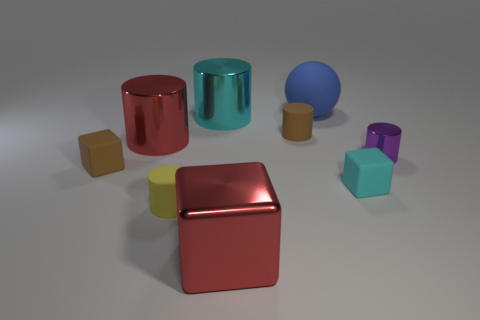Subtract all rubber cylinders. How many cylinders are left? 3 Subtract all yellow cylinders. How many cylinders are left? 4 Subtract 2 cylinders. How many cylinders are left? 3 Subtract all yellow cylinders. Subtract all gray cubes. How many cylinders are left? 4 Add 1 tiny cyan things. How many objects exist? 10 Subtract all cylinders. How many objects are left? 4 Add 1 big red rubber balls. How many big red rubber balls exist? 1 Subtract 1 cyan cylinders. How many objects are left? 8 Subtract all large matte balls. Subtract all small things. How many objects are left? 3 Add 9 purple things. How many purple things are left? 10 